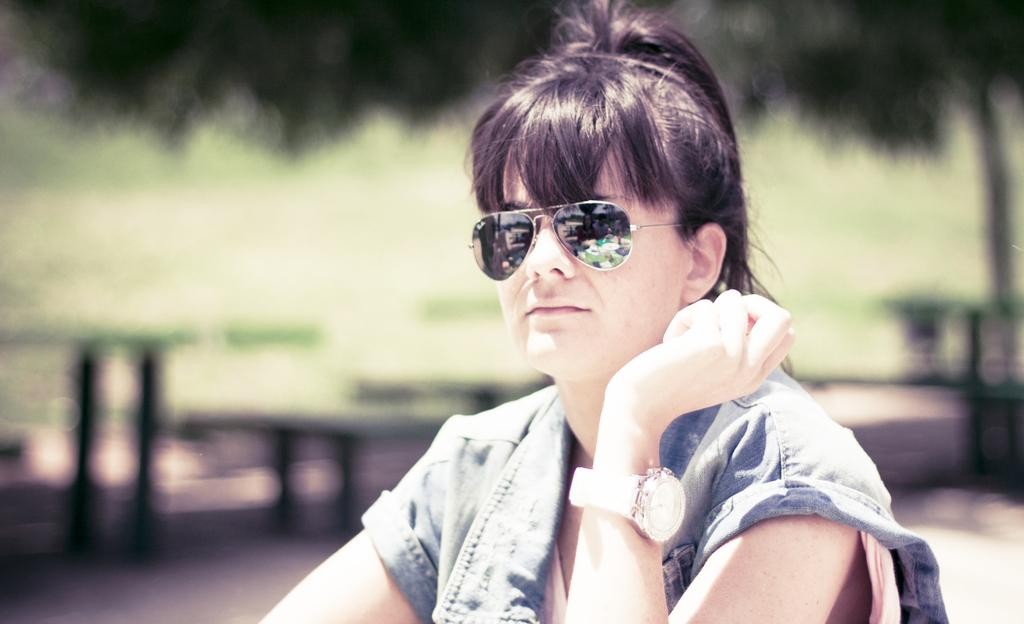What is the main subject of the image? There is a person sitting in the image. Can you describe the background of the image? The background of the image is blurred. How many cups of coffee does the person have in the image? There is no mention of cups of coffee or any other objects besides the person sitting in the image. Are there any chickens visible in the image? No, there are no chickens present in the image. 